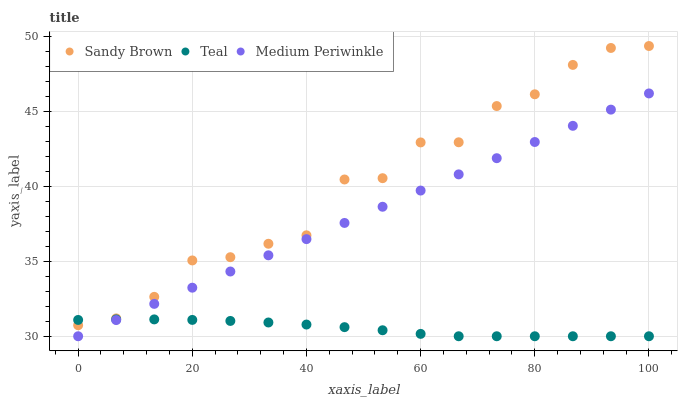Does Teal have the minimum area under the curve?
Answer yes or no. Yes. Does Sandy Brown have the maximum area under the curve?
Answer yes or no. Yes. Does Sandy Brown have the minimum area under the curve?
Answer yes or no. No. Does Teal have the maximum area under the curve?
Answer yes or no. No. Is Medium Periwinkle the smoothest?
Answer yes or no. Yes. Is Sandy Brown the roughest?
Answer yes or no. Yes. Is Teal the smoothest?
Answer yes or no. No. Is Teal the roughest?
Answer yes or no. No. Does Medium Periwinkle have the lowest value?
Answer yes or no. Yes. Does Sandy Brown have the lowest value?
Answer yes or no. No. Does Sandy Brown have the highest value?
Answer yes or no. Yes. Does Teal have the highest value?
Answer yes or no. No. Is Medium Periwinkle less than Sandy Brown?
Answer yes or no. Yes. Is Sandy Brown greater than Medium Periwinkle?
Answer yes or no. Yes. Does Teal intersect Sandy Brown?
Answer yes or no. Yes. Is Teal less than Sandy Brown?
Answer yes or no. No. Is Teal greater than Sandy Brown?
Answer yes or no. No. Does Medium Periwinkle intersect Sandy Brown?
Answer yes or no. No. 